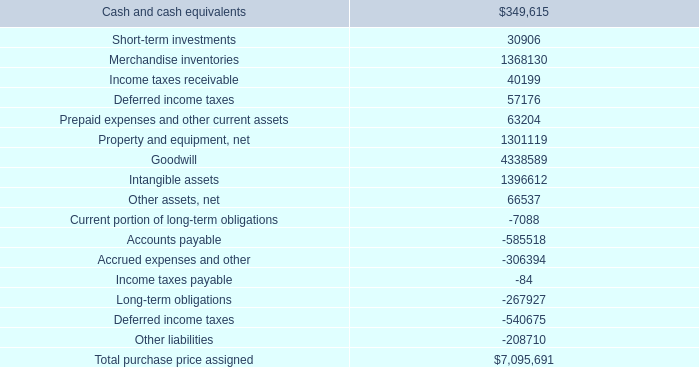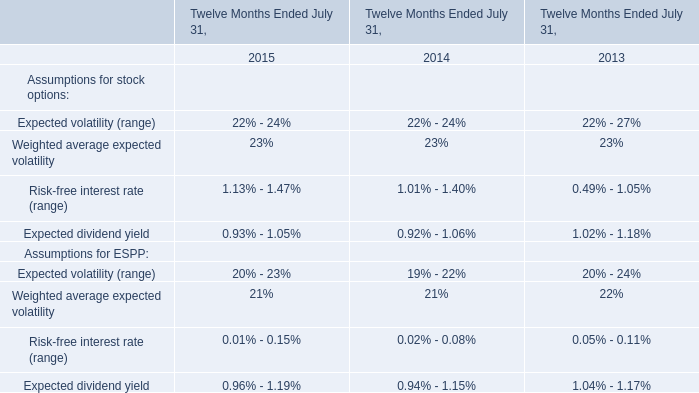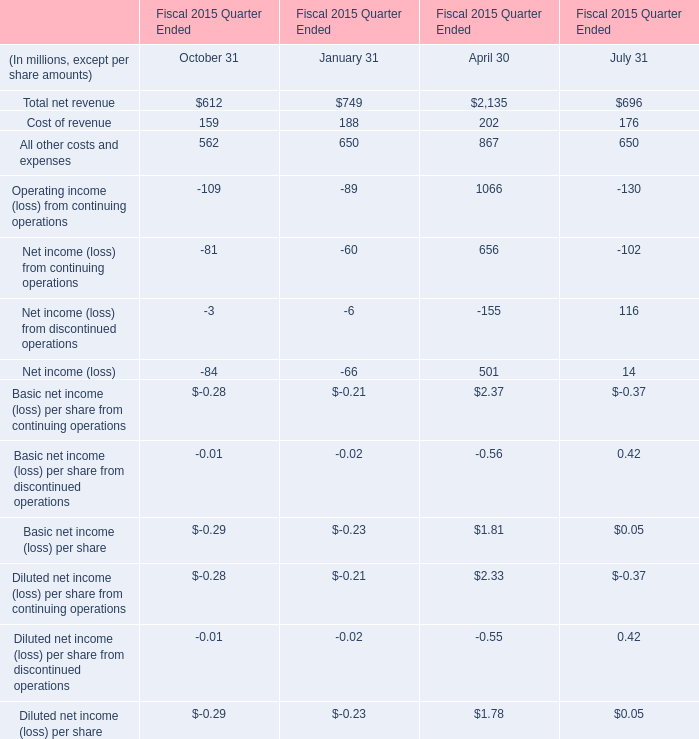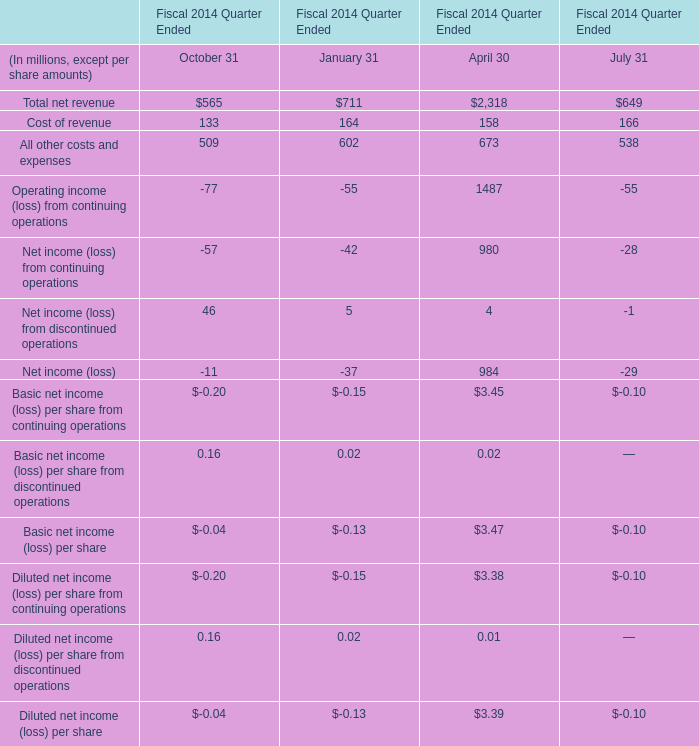What's the total value of all October 31 that are smaller than -80 in 2015? (in million) 
Computations: (-81 - 109)
Answer: -190.0. 